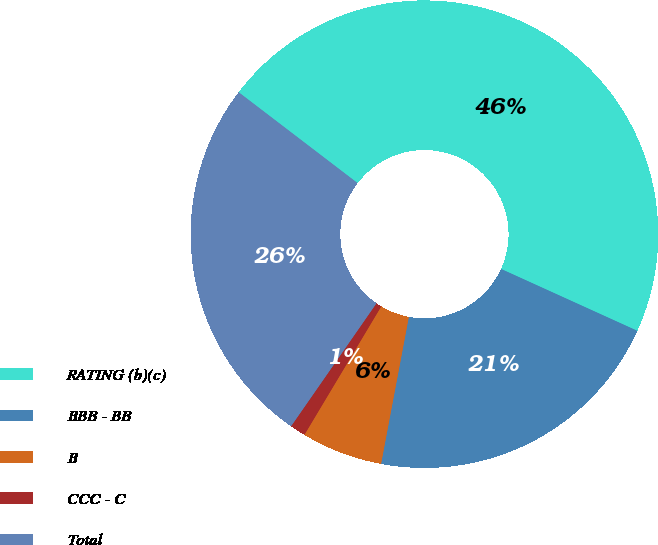Convert chart to OTSL. <chart><loc_0><loc_0><loc_500><loc_500><pie_chart><fcel>RATING (b)(c)<fcel>BBB - BB<fcel>B<fcel>CCC - C<fcel>Total<nl><fcel>46.4%<fcel>21.19%<fcel>5.61%<fcel>1.08%<fcel>25.72%<nl></chart> 